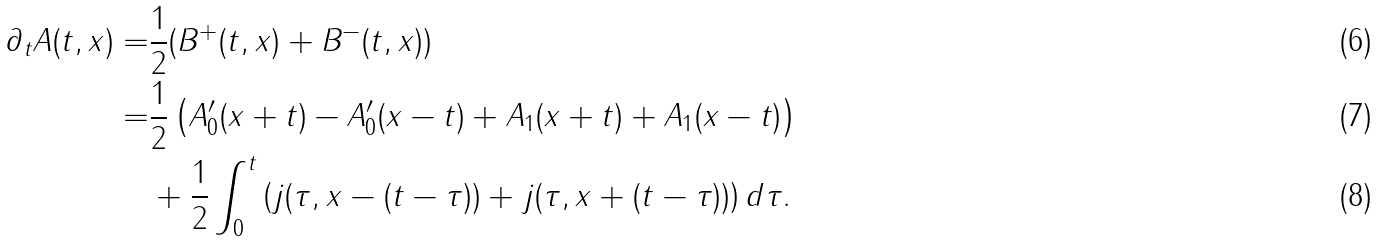<formula> <loc_0><loc_0><loc_500><loc_500>\partial _ { t } A ( t , x ) = & \frac { 1 } { 2 } ( B ^ { + } ( t , x ) + B ^ { - } ( t , x ) ) \\ = & \frac { 1 } { 2 } \left ( A _ { 0 } ^ { \prime } ( x + t ) - A _ { 0 } ^ { \prime } ( x - t ) + A _ { 1 } ( x + t ) + A _ { 1 } ( x - t ) \right ) \\ & + \frac { 1 } { 2 } \int _ { 0 } ^ { t } \left ( j ( \tau , x - ( t - \tau ) ) + j ( \tau , x + ( t - \tau ) ) \right ) d \tau .</formula> 